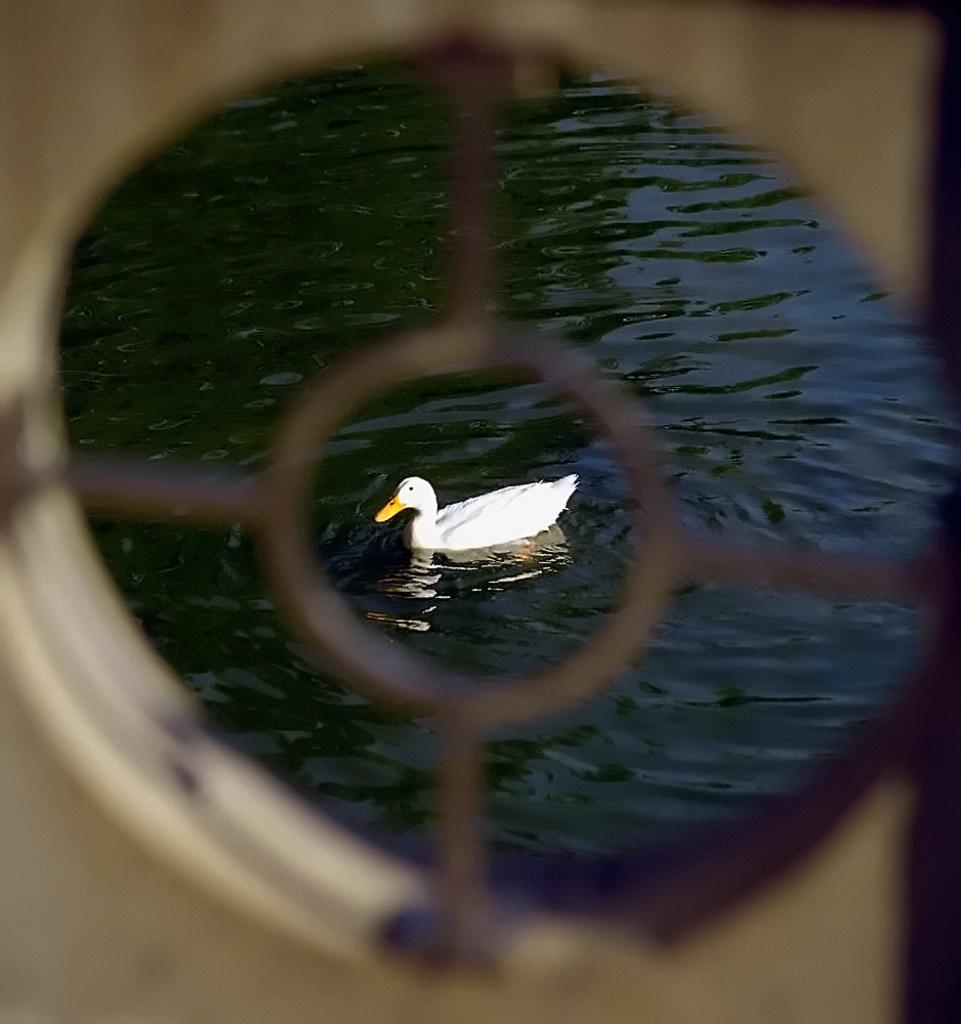Could you give a brief overview of what you see in this image? There is a white duck on the water. 